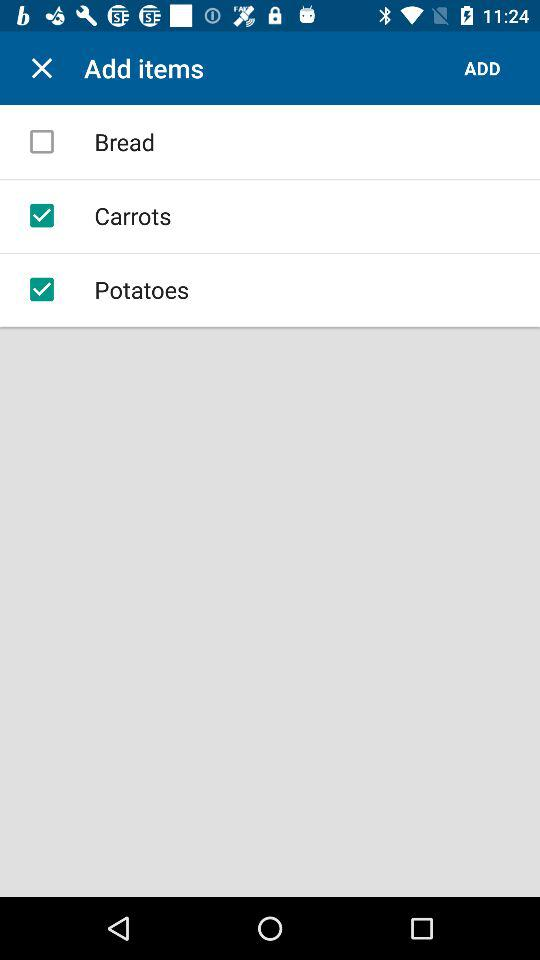What are the food items available? The available food items are "Bread", "Carrot" and "Potatoes". 